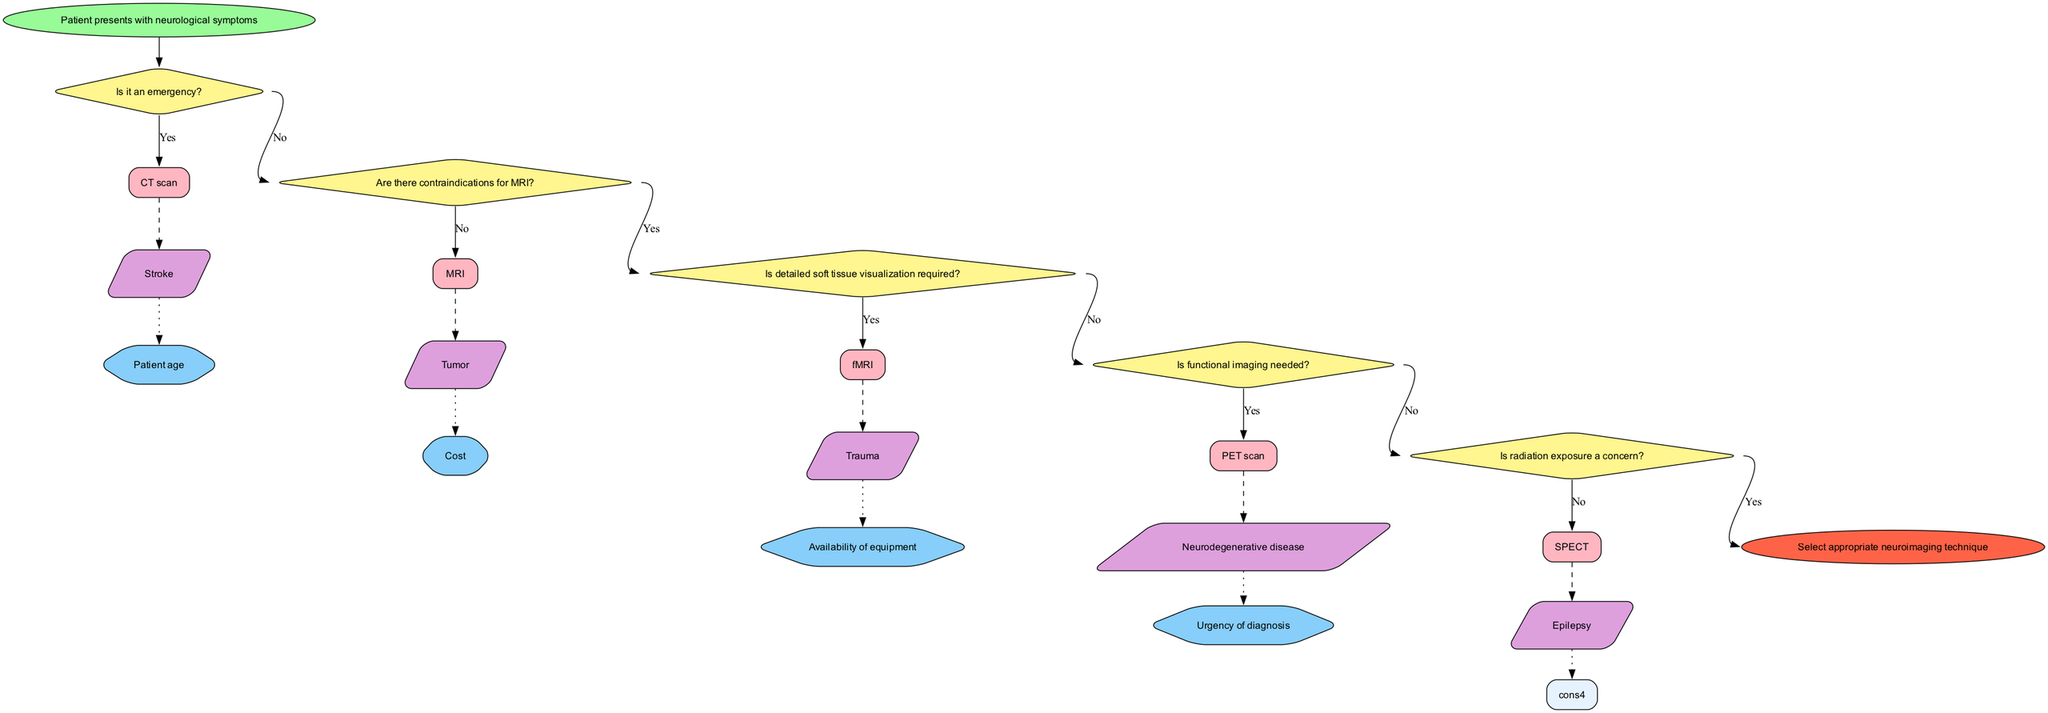What is the starting point of the decision-making process? The starting point of the process is identified as "Patient presents with neurological symptoms," which is the first node in the flowchart.
Answer: Patient presents with neurological symptoms How many decision points are present in the diagram? By counting the decision nodes labeled as diamonds, we can see there are a total of five decision points in the diagram.
Answer: 5 What imaging technique is chosen if it's an emergency? According to the flowchart, if the situation is an emergency, the selected imaging technique is a CT scan, as indicated by the "Yes" branch from the first decision point.
Answer: CT scan Which imaging technique requires consideration of radiation exposure? Reviewing the decision branches, radiation exposure is a concern for the CT scan, hence it is a consideration when deciding on this imaging technique.
Answer: CT scan What happens if detailed soft tissue visualization is required? In the flow of the diagram, if detailed soft tissue visualization is necessary, it leads to choosing an MRI, indicated by the "Yes" path from the decision point relevant to this need.
Answer: MRI If the patient has contraindications for MRI, what technique is selected? Following the flow of decisions, if there are contraindications for MRI, the next evaluation would lead to the use of a CT scan, based on the "No" answer in the decision process.
Answer: CT scan Which imaging technique is chosen when functional imaging is needed? The flowchart explicitly states that if functional imaging is needed, the process leads to selecting an fMRI, following the positive response path from the respective decision point.
Answer: fMRI What do considerations such as patient age influence in the diagram? Patient age, along with other factors, influences the selection of the appropriate imaging technique, affecting decisions at various points in the flowchart depending on the scenario assessed.
Answer: Selection of imaging technique Which imaging technique is indicated for diagnosing neurodegenerative disease according to the flowchart? The flowchart illustrates that for neurodegenerative disease, the recommended imaging technique is a PET scan, confirmed by the connection in the specific decision node.
Answer: PET scan 